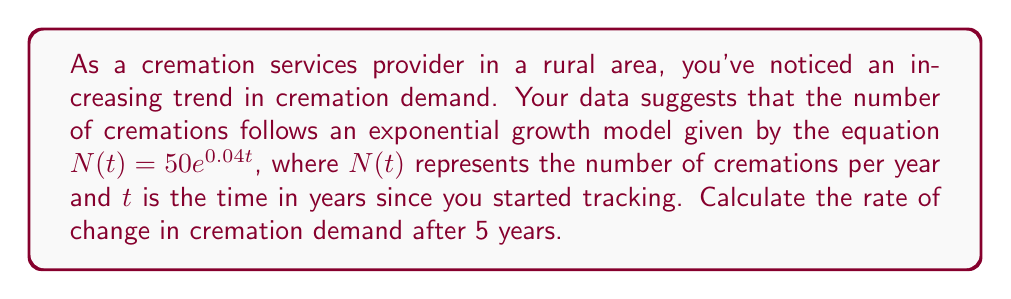Solve this math problem. To solve this problem, we need to follow these steps:

1) The given exponential growth model is:
   $N(t) = 50e^{0.04t}$

2) To find the rate of change, we need to differentiate this function with respect to t:
   $\frac{dN}{dt} = 50 \cdot 0.04e^{0.04t} = 2e^{0.04t}$

3) This derivative represents the instantaneous rate of change at any given time t.

4) To find the rate of change after 5 years, we substitute t = 5 into this derivative:
   $\frac{dN}{dt}\bigg|_{t=5} = 2e^{0.04(5)} = 2e^{0.2}$

5) Calculate the value:
   $2e^{0.2} \approx 2.4428$

Therefore, after 5 years, the rate of change in cremation demand is approximately 2.4428 cremations per year per year.
Answer: $\frac{dN}{dt}\bigg|_{t=5} \approx 2.4428$ cremations/year² 